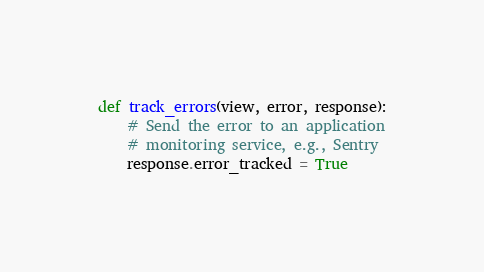Convert code to text. <code><loc_0><loc_0><loc_500><loc_500><_Python_>

def track_errors(view, error, response):
    # Send the error to an application
    # monitoring service, e.g., Sentry
    response.error_tracked = True
</code> 